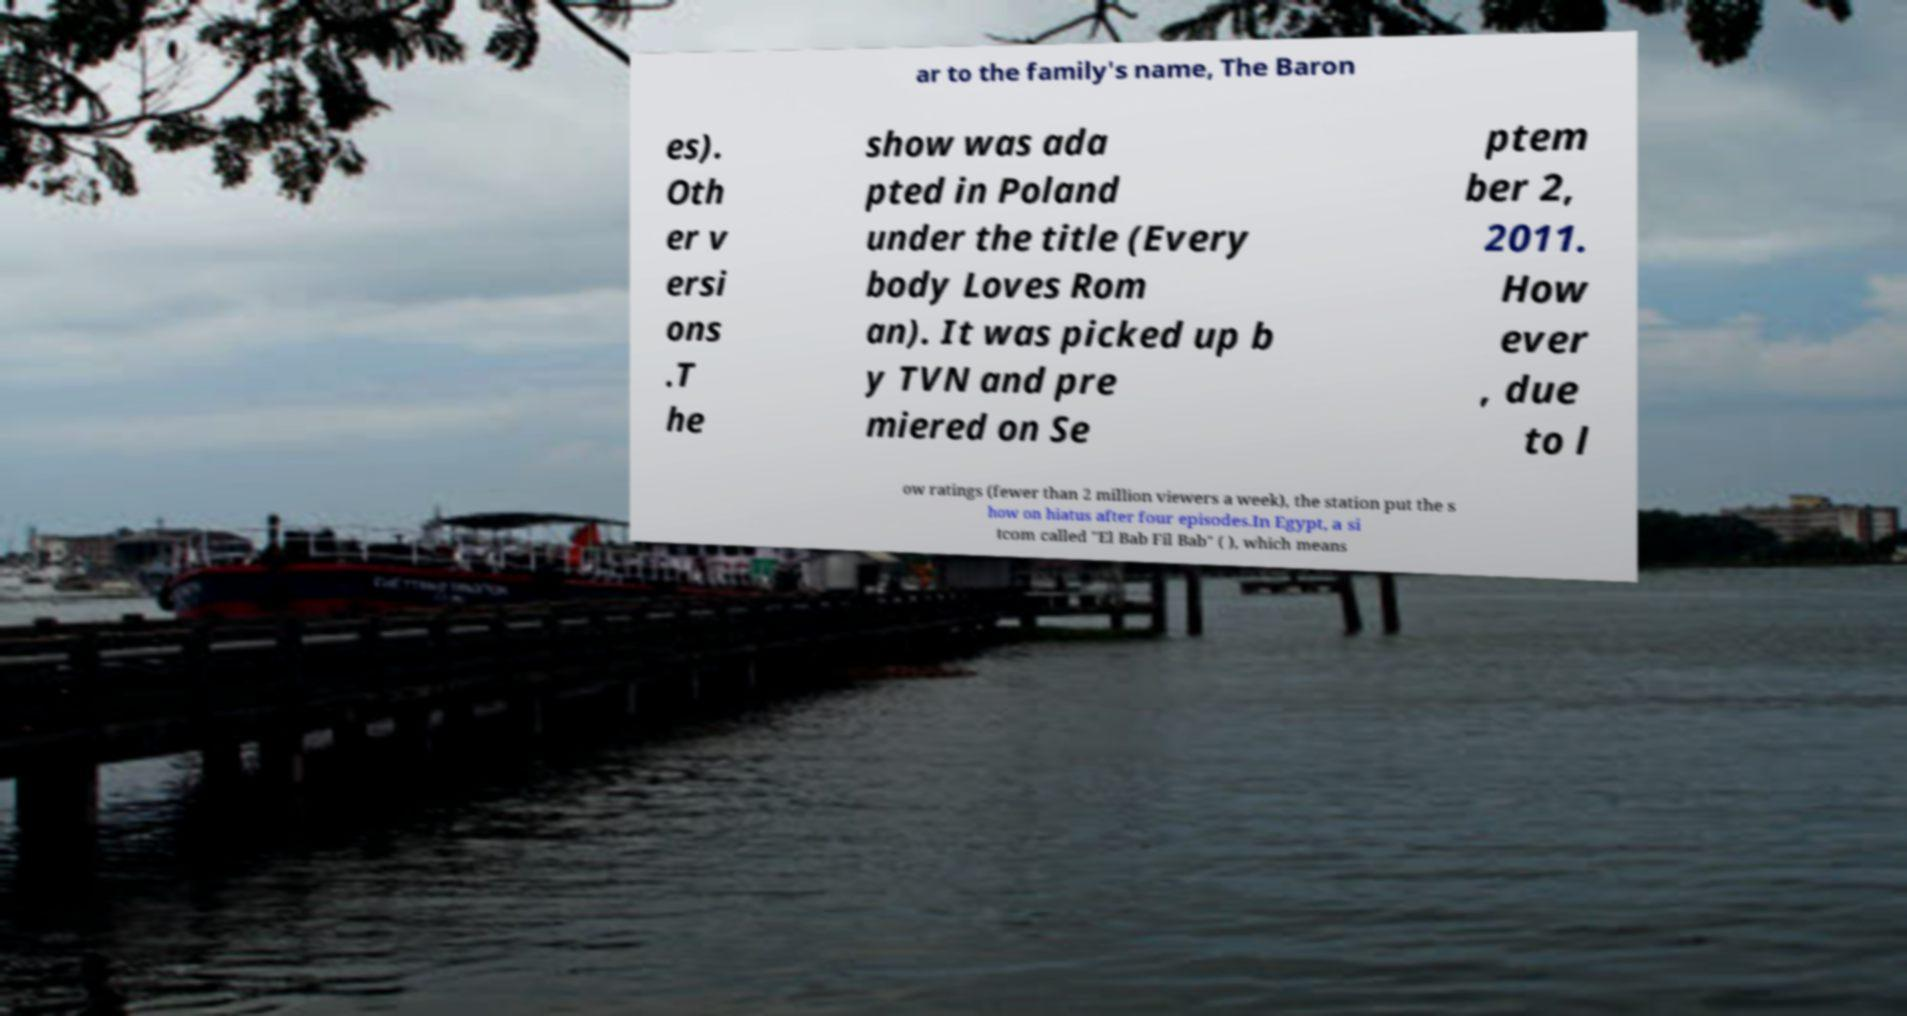What messages or text are displayed in this image? I need them in a readable, typed format. ar to the family's name, The Baron es). Oth er v ersi ons .T he show was ada pted in Poland under the title (Every body Loves Rom an). It was picked up b y TVN and pre miered on Se ptem ber 2, 2011. How ever , due to l ow ratings (fewer than 2 million viewers a week), the station put the s how on hiatus after four episodes.In Egypt, a si tcom called "El Bab Fil Bab" ( ), which means 